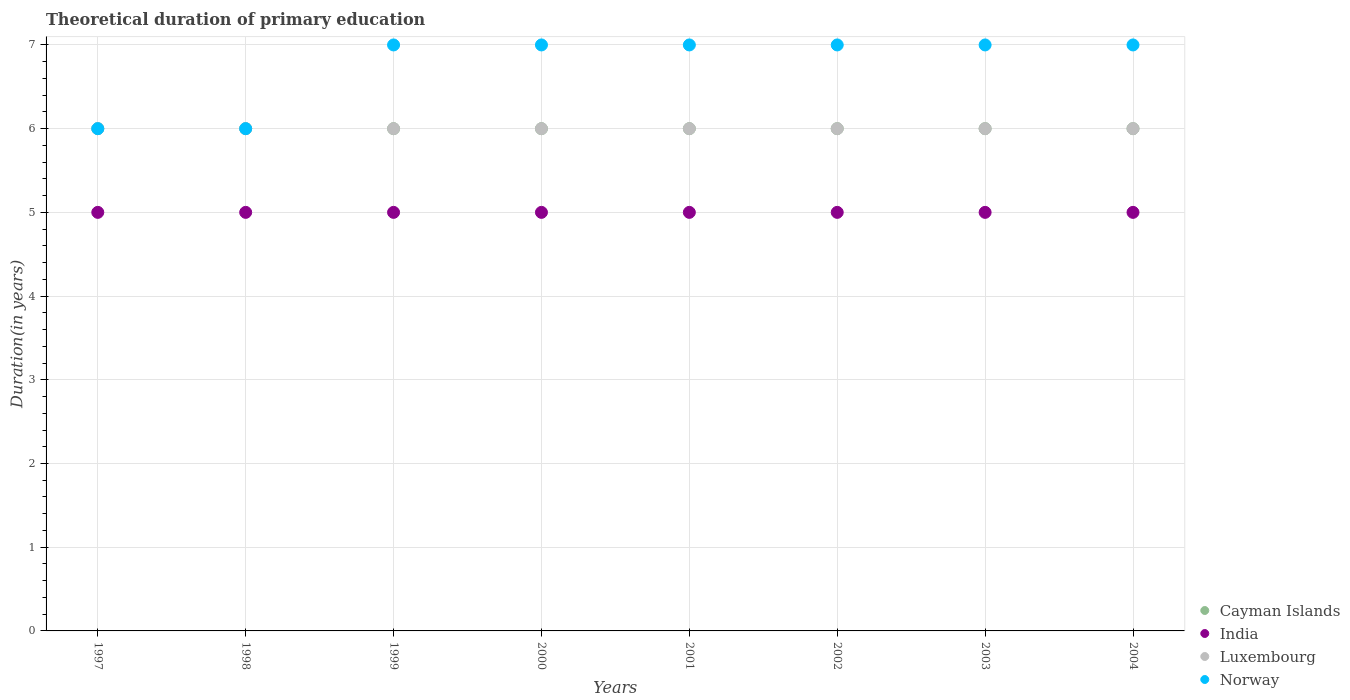How many different coloured dotlines are there?
Your response must be concise. 4. What is the total theoretical duration of primary education in Luxembourg in 2001?
Your answer should be very brief. 6. Across all years, what is the maximum total theoretical duration of primary education in Norway?
Offer a very short reply. 7. Across all years, what is the minimum total theoretical duration of primary education in India?
Your answer should be compact. 5. In which year was the total theoretical duration of primary education in Norway maximum?
Provide a succinct answer. 1999. In which year was the total theoretical duration of primary education in Norway minimum?
Give a very brief answer. 1997. What is the total total theoretical duration of primary education in India in the graph?
Give a very brief answer. 40. What is the average total theoretical duration of primary education in Norway per year?
Your response must be concise. 6.75. In the year 1997, what is the difference between the total theoretical duration of primary education in Cayman Islands and total theoretical duration of primary education in India?
Keep it short and to the point. 1. Is the total theoretical duration of primary education in Norway in 1999 less than that in 2003?
Your answer should be very brief. No. What is the difference between the highest and the second highest total theoretical duration of primary education in Cayman Islands?
Keep it short and to the point. 0. What is the difference between the highest and the lowest total theoretical duration of primary education in Norway?
Offer a terse response. 1. Is the sum of the total theoretical duration of primary education in India in 1999 and 2000 greater than the maximum total theoretical duration of primary education in Luxembourg across all years?
Give a very brief answer. Yes. Is it the case that in every year, the sum of the total theoretical duration of primary education in Luxembourg and total theoretical duration of primary education in India  is greater than the sum of total theoretical duration of primary education in Norway and total theoretical duration of primary education in Cayman Islands?
Offer a terse response. Yes. Is it the case that in every year, the sum of the total theoretical duration of primary education in Luxembourg and total theoretical duration of primary education in Norway  is greater than the total theoretical duration of primary education in India?
Offer a terse response. Yes. Does the total theoretical duration of primary education in Norway monotonically increase over the years?
Offer a terse response. No. Is the total theoretical duration of primary education in Luxembourg strictly greater than the total theoretical duration of primary education in Norway over the years?
Give a very brief answer. No. Is the total theoretical duration of primary education in Cayman Islands strictly less than the total theoretical duration of primary education in India over the years?
Provide a succinct answer. No. How many dotlines are there?
Make the answer very short. 4. How many years are there in the graph?
Your answer should be very brief. 8. Does the graph contain any zero values?
Offer a terse response. No. Where does the legend appear in the graph?
Provide a short and direct response. Bottom right. How many legend labels are there?
Provide a succinct answer. 4. How are the legend labels stacked?
Your answer should be compact. Vertical. What is the title of the graph?
Your answer should be very brief. Theoretical duration of primary education. Does "Kyrgyz Republic" appear as one of the legend labels in the graph?
Make the answer very short. No. What is the label or title of the Y-axis?
Ensure brevity in your answer.  Duration(in years). What is the Duration(in years) of Cayman Islands in 1997?
Offer a terse response. 6. What is the Duration(in years) in India in 1997?
Your answer should be very brief. 5. What is the Duration(in years) of Cayman Islands in 1998?
Your response must be concise. 6. What is the Duration(in years) of Luxembourg in 1998?
Your answer should be very brief. 6. What is the Duration(in years) of Norway in 1998?
Give a very brief answer. 6. What is the Duration(in years) of India in 1999?
Your response must be concise. 5. What is the Duration(in years) of Luxembourg in 1999?
Your answer should be compact. 6. What is the Duration(in years) of Norway in 1999?
Your response must be concise. 7. What is the Duration(in years) of India in 2000?
Offer a very short reply. 5. What is the Duration(in years) in Cayman Islands in 2001?
Your answer should be compact. 6. What is the Duration(in years) of India in 2001?
Provide a short and direct response. 5. What is the Duration(in years) of Cayman Islands in 2002?
Provide a short and direct response. 6. What is the Duration(in years) of Cayman Islands in 2003?
Keep it short and to the point. 6. What is the Duration(in years) of India in 2003?
Your response must be concise. 5. What is the Duration(in years) of Luxembourg in 2003?
Your answer should be compact. 6. What is the Duration(in years) of Cayman Islands in 2004?
Offer a terse response. 6. What is the Duration(in years) in Norway in 2004?
Make the answer very short. 7. Across all years, what is the maximum Duration(in years) of Cayman Islands?
Ensure brevity in your answer.  6. Across all years, what is the maximum Duration(in years) of Luxembourg?
Offer a very short reply. 6. Across all years, what is the minimum Duration(in years) in India?
Your response must be concise. 5. What is the total Duration(in years) in Norway in the graph?
Offer a very short reply. 54. What is the difference between the Duration(in years) in Cayman Islands in 1997 and that in 1999?
Provide a succinct answer. 0. What is the difference between the Duration(in years) in Norway in 1997 and that in 1999?
Your answer should be compact. -1. What is the difference between the Duration(in years) of India in 1997 and that in 2000?
Ensure brevity in your answer.  0. What is the difference between the Duration(in years) of Luxembourg in 1997 and that in 2000?
Provide a succinct answer. 0. What is the difference between the Duration(in years) of Norway in 1997 and that in 2000?
Make the answer very short. -1. What is the difference between the Duration(in years) in Cayman Islands in 1997 and that in 2001?
Ensure brevity in your answer.  0. What is the difference between the Duration(in years) of India in 1997 and that in 2001?
Give a very brief answer. 0. What is the difference between the Duration(in years) in Norway in 1997 and that in 2001?
Offer a very short reply. -1. What is the difference between the Duration(in years) of India in 1997 and that in 2002?
Provide a short and direct response. 0. What is the difference between the Duration(in years) of Cayman Islands in 1997 and that in 2003?
Your answer should be very brief. 0. What is the difference between the Duration(in years) of Luxembourg in 1997 and that in 2003?
Ensure brevity in your answer.  0. What is the difference between the Duration(in years) in India in 1997 and that in 2004?
Give a very brief answer. 0. What is the difference between the Duration(in years) of Luxembourg in 1997 and that in 2004?
Make the answer very short. 0. What is the difference between the Duration(in years) of Norway in 1997 and that in 2004?
Your response must be concise. -1. What is the difference between the Duration(in years) of Luxembourg in 1998 and that in 1999?
Make the answer very short. 0. What is the difference between the Duration(in years) in Cayman Islands in 1998 and that in 2000?
Make the answer very short. 0. What is the difference between the Duration(in years) of India in 1998 and that in 2000?
Offer a very short reply. 0. What is the difference between the Duration(in years) of Luxembourg in 1998 and that in 2000?
Make the answer very short. 0. What is the difference between the Duration(in years) in Cayman Islands in 1998 and that in 2001?
Your response must be concise. 0. What is the difference between the Duration(in years) in India in 1998 and that in 2001?
Offer a very short reply. 0. What is the difference between the Duration(in years) of Luxembourg in 1998 and that in 2001?
Keep it short and to the point. 0. What is the difference between the Duration(in years) in Luxembourg in 1998 and that in 2002?
Offer a terse response. 0. What is the difference between the Duration(in years) of Norway in 1998 and that in 2002?
Offer a terse response. -1. What is the difference between the Duration(in years) of India in 1998 and that in 2004?
Your response must be concise. 0. What is the difference between the Duration(in years) in Luxembourg in 1999 and that in 2000?
Your answer should be very brief. 0. What is the difference between the Duration(in years) in Norway in 1999 and that in 2000?
Offer a terse response. 0. What is the difference between the Duration(in years) of India in 1999 and that in 2001?
Provide a short and direct response. 0. What is the difference between the Duration(in years) of Luxembourg in 1999 and that in 2001?
Make the answer very short. 0. What is the difference between the Duration(in years) of Norway in 1999 and that in 2001?
Keep it short and to the point. 0. What is the difference between the Duration(in years) of Cayman Islands in 1999 and that in 2002?
Your answer should be very brief. 0. What is the difference between the Duration(in years) in Luxembourg in 1999 and that in 2002?
Your answer should be very brief. 0. What is the difference between the Duration(in years) in Norway in 1999 and that in 2002?
Your answer should be compact. 0. What is the difference between the Duration(in years) in India in 1999 and that in 2003?
Offer a very short reply. 0. What is the difference between the Duration(in years) in Luxembourg in 1999 and that in 2003?
Your answer should be compact. 0. What is the difference between the Duration(in years) in Norway in 1999 and that in 2003?
Offer a very short reply. 0. What is the difference between the Duration(in years) of Cayman Islands in 2000 and that in 2001?
Ensure brevity in your answer.  0. What is the difference between the Duration(in years) in Luxembourg in 2000 and that in 2001?
Make the answer very short. 0. What is the difference between the Duration(in years) of Norway in 2000 and that in 2001?
Offer a terse response. 0. What is the difference between the Duration(in years) in India in 2000 and that in 2002?
Ensure brevity in your answer.  0. What is the difference between the Duration(in years) of Norway in 2000 and that in 2002?
Give a very brief answer. 0. What is the difference between the Duration(in years) of Luxembourg in 2000 and that in 2003?
Your answer should be very brief. 0. What is the difference between the Duration(in years) of Norway in 2000 and that in 2003?
Your answer should be very brief. 0. What is the difference between the Duration(in years) in India in 2000 and that in 2004?
Provide a succinct answer. 0. What is the difference between the Duration(in years) of Norway in 2000 and that in 2004?
Make the answer very short. 0. What is the difference between the Duration(in years) in Cayman Islands in 2001 and that in 2002?
Keep it short and to the point. 0. What is the difference between the Duration(in years) in India in 2001 and that in 2002?
Keep it short and to the point. 0. What is the difference between the Duration(in years) of Cayman Islands in 2001 and that in 2003?
Offer a terse response. 0. What is the difference between the Duration(in years) in Norway in 2001 and that in 2004?
Provide a short and direct response. 0. What is the difference between the Duration(in years) in India in 2002 and that in 2003?
Give a very brief answer. 0. What is the difference between the Duration(in years) in Cayman Islands in 2002 and that in 2004?
Keep it short and to the point. 0. What is the difference between the Duration(in years) of India in 2002 and that in 2004?
Keep it short and to the point. 0. What is the difference between the Duration(in years) in Norway in 2002 and that in 2004?
Your answer should be compact. 0. What is the difference between the Duration(in years) in India in 2003 and that in 2004?
Make the answer very short. 0. What is the difference between the Duration(in years) in Norway in 2003 and that in 2004?
Offer a very short reply. 0. What is the difference between the Duration(in years) in Cayman Islands in 1997 and the Duration(in years) in India in 1998?
Provide a short and direct response. 1. What is the difference between the Duration(in years) of Cayman Islands in 1997 and the Duration(in years) of Luxembourg in 1998?
Make the answer very short. 0. What is the difference between the Duration(in years) of India in 1997 and the Duration(in years) of Luxembourg in 1998?
Offer a very short reply. -1. What is the difference between the Duration(in years) in Cayman Islands in 1997 and the Duration(in years) in India in 1999?
Make the answer very short. 1. What is the difference between the Duration(in years) of Cayman Islands in 1997 and the Duration(in years) of Luxembourg in 1999?
Make the answer very short. 0. What is the difference between the Duration(in years) of India in 1997 and the Duration(in years) of Norway in 1999?
Your answer should be compact. -2. What is the difference between the Duration(in years) of Luxembourg in 1997 and the Duration(in years) of Norway in 1999?
Provide a short and direct response. -1. What is the difference between the Duration(in years) in Cayman Islands in 1997 and the Duration(in years) in Luxembourg in 2000?
Offer a terse response. 0. What is the difference between the Duration(in years) in India in 1997 and the Duration(in years) in Luxembourg in 2000?
Your answer should be very brief. -1. What is the difference between the Duration(in years) of Cayman Islands in 1997 and the Duration(in years) of India in 2001?
Offer a terse response. 1. What is the difference between the Duration(in years) in India in 1997 and the Duration(in years) in Norway in 2001?
Keep it short and to the point. -2. What is the difference between the Duration(in years) in Cayman Islands in 1997 and the Duration(in years) in Luxembourg in 2002?
Offer a very short reply. 0. What is the difference between the Duration(in years) in India in 1997 and the Duration(in years) in Luxembourg in 2002?
Your response must be concise. -1. What is the difference between the Duration(in years) of India in 1997 and the Duration(in years) of Norway in 2002?
Keep it short and to the point. -2. What is the difference between the Duration(in years) in Cayman Islands in 1997 and the Duration(in years) in India in 2003?
Ensure brevity in your answer.  1. What is the difference between the Duration(in years) in Cayman Islands in 1997 and the Duration(in years) in Norway in 2003?
Provide a short and direct response. -1. What is the difference between the Duration(in years) in India in 1997 and the Duration(in years) in Norway in 2003?
Offer a terse response. -2. What is the difference between the Duration(in years) in Luxembourg in 1997 and the Duration(in years) in Norway in 2003?
Your response must be concise. -1. What is the difference between the Duration(in years) of Cayman Islands in 1997 and the Duration(in years) of India in 2004?
Keep it short and to the point. 1. What is the difference between the Duration(in years) in India in 1997 and the Duration(in years) in Luxembourg in 2004?
Keep it short and to the point. -1. What is the difference between the Duration(in years) of Cayman Islands in 1998 and the Duration(in years) of India in 1999?
Your answer should be compact. 1. What is the difference between the Duration(in years) of Cayman Islands in 1998 and the Duration(in years) of Luxembourg in 1999?
Your answer should be compact. 0. What is the difference between the Duration(in years) of India in 1998 and the Duration(in years) of Norway in 1999?
Offer a very short reply. -2. What is the difference between the Duration(in years) in Luxembourg in 1998 and the Duration(in years) in Norway in 1999?
Ensure brevity in your answer.  -1. What is the difference between the Duration(in years) in Cayman Islands in 1998 and the Duration(in years) in India in 2000?
Provide a succinct answer. 1. What is the difference between the Duration(in years) of Cayman Islands in 1998 and the Duration(in years) of Luxembourg in 2000?
Offer a very short reply. 0. What is the difference between the Duration(in years) of India in 1998 and the Duration(in years) of Norway in 2000?
Offer a very short reply. -2. What is the difference between the Duration(in years) of Luxembourg in 1998 and the Duration(in years) of Norway in 2000?
Offer a very short reply. -1. What is the difference between the Duration(in years) in India in 1998 and the Duration(in years) in Norway in 2001?
Ensure brevity in your answer.  -2. What is the difference between the Duration(in years) in Luxembourg in 1998 and the Duration(in years) in Norway in 2001?
Your answer should be very brief. -1. What is the difference between the Duration(in years) of Cayman Islands in 1998 and the Duration(in years) of Norway in 2002?
Your answer should be compact. -1. What is the difference between the Duration(in years) in India in 1998 and the Duration(in years) in Luxembourg in 2002?
Your response must be concise. -1. What is the difference between the Duration(in years) in India in 1998 and the Duration(in years) in Norway in 2002?
Your answer should be compact. -2. What is the difference between the Duration(in years) in Luxembourg in 1998 and the Duration(in years) in Norway in 2002?
Offer a terse response. -1. What is the difference between the Duration(in years) in India in 1998 and the Duration(in years) in Luxembourg in 2003?
Your response must be concise. -1. What is the difference between the Duration(in years) of Cayman Islands in 1998 and the Duration(in years) of India in 2004?
Ensure brevity in your answer.  1. What is the difference between the Duration(in years) in Cayman Islands in 1998 and the Duration(in years) in Luxembourg in 2004?
Your answer should be compact. 0. What is the difference between the Duration(in years) in Cayman Islands in 1998 and the Duration(in years) in Norway in 2004?
Ensure brevity in your answer.  -1. What is the difference between the Duration(in years) in Cayman Islands in 1999 and the Duration(in years) in Luxembourg in 2000?
Give a very brief answer. 0. What is the difference between the Duration(in years) of India in 1999 and the Duration(in years) of Norway in 2000?
Offer a very short reply. -2. What is the difference between the Duration(in years) of Luxembourg in 1999 and the Duration(in years) of Norway in 2000?
Provide a short and direct response. -1. What is the difference between the Duration(in years) in India in 1999 and the Duration(in years) in Luxembourg in 2001?
Offer a very short reply. -1. What is the difference between the Duration(in years) of Cayman Islands in 1999 and the Duration(in years) of India in 2002?
Offer a very short reply. 1. What is the difference between the Duration(in years) of Cayman Islands in 1999 and the Duration(in years) of Luxembourg in 2002?
Keep it short and to the point. 0. What is the difference between the Duration(in years) of India in 1999 and the Duration(in years) of Norway in 2002?
Ensure brevity in your answer.  -2. What is the difference between the Duration(in years) of Cayman Islands in 1999 and the Duration(in years) of India in 2003?
Your response must be concise. 1. What is the difference between the Duration(in years) of Cayman Islands in 1999 and the Duration(in years) of Luxembourg in 2003?
Offer a very short reply. 0. What is the difference between the Duration(in years) in India in 1999 and the Duration(in years) in Luxembourg in 2003?
Offer a terse response. -1. What is the difference between the Duration(in years) in India in 1999 and the Duration(in years) in Norway in 2003?
Offer a very short reply. -2. What is the difference between the Duration(in years) of Cayman Islands in 1999 and the Duration(in years) of Luxembourg in 2004?
Your answer should be very brief. 0. What is the difference between the Duration(in years) of India in 1999 and the Duration(in years) of Luxembourg in 2004?
Your answer should be very brief. -1. What is the difference between the Duration(in years) of India in 1999 and the Duration(in years) of Norway in 2004?
Keep it short and to the point. -2. What is the difference between the Duration(in years) of Cayman Islands in 2000 and the Duration(in years) of India in 2001?
Your answer should be very brief. 1. What is the difference between the Duration(in years) in Cayman Islands in 2000 and the Duration(in years) in Luxembourg in 2001?
Make the answer very short. 0. What is the difference between the Duration(in years) in Cayman Islands in 2000 and the Duration(in years) in Norway in 2001?
Give a very brief answer. -1. What is the difference between the Duration(in years) in Luxembourg in 2000 and the Duration(in years) in Norway in 2001?
Offer a very short reply. -1. What is the difference between the Duration(in years) in Cayman Islands in 2000 and the Duration(in years) in India in 2002?
Your answer should be compact. 1. What is the difference between the Duration(in years) of Cayman Islands in 2000 and the Duration(in years) of Luxembourg in 2002?
Ensure brevity in your answer.  0. What is the difference between the Duration(in years) in Cayman Islands in 2000 and the Duration(in years) in Norway in 2002?
Give a very brief answer. -1. What is the difference between the Duration(in years) in India in 2000 and the Duration(in years) in Luxembourg in 2002?
Give a very brief answer. -1. What is the difference between the Duration(in years) of India in 2000 and the Duration(in years) of Norway in 2002?
Your response must be concise. -2. What is the difference between the Duration(in years) in Cayman Islands in 2000 and the Duration(in years) in India in 2003?
Provide a succinct answer. 1. What is the difference between the Duration(in years) in Cayman Islands in 2000 and the Duration(in years) in Luxembourg in 2003?
Your answer should be compact. 0. What is the difference between the Duration(in years) in Cayman Islands in 2000 and the Duration(in years) in Norway in 2003?
Your answer should be very brief. -1. What is the difference between the Duration(in years) in India in 2000 and the Duration(in years) in Luxembourg in 2003?
Offer a very short reply. -1. What is the difference between the Duration(in years) in India in 2000 and the Duration(in years) in Norway in 2003?
Keep it short and to the point. -2. What is the difference between the Duration(in years) of Cayman Islands in 2000 and the Duration(in years) of India in 2004?
Give a very brief answer. 1. What is the difference between the Duration(in years) in Cayman Islands in 2000 and the Duration(in years) in Norway in 2004?
Give a very brief answer. -1. What is the difference between the Duration(in years) of India in 2000 and the Duration(in years) of Luxembourg in 2004?
Keep it short and to the point. -1. What is the difference between the Duration(in years) in India in 2000 and the Duration(in years) in Norway in 2004?
Give a very brief answer. -2. What is the difference between the Duration(in years) of Cayman Islands in 2001 and the Duration(in years) of India in 2002?
Provide a succinct answer. 1. What is the difference between the Duration(in years) in Cayman Islands in 2001 and the Duration(in years) in Luxembourg in 2002?
Keep it short and to the point. 0. What is the difference between the Duration(in years) in Cayman Islands in 2001 and the Duration(in years) in Norway in 2002?
Provide a short and direct response. -1. What is the difference between the Duration(in years) of India in 2001 and the Duration(in years) of Norway in 2002?
Make the answer very short. -2. What is the difference between the Duration(in years) of Cayman Islands in 2001 and the Duration(in years) of Norway in 2003?
Ensure brevity in your answer.  -1. What is the difference between the Duration(in years) in Cayman Islands in 2001 and the Duration(in years) in Luxembourg in 2004?
Your answer should be compact. 0. What is the difference between the Duration(in years) of Cayman Islands in 2001 and the Duration(in years) of Norway in 2004?
Give a very brief answer. -1. What is the difference between the Duration(in years) of India in 2001 and the Duration(in years) of Luxembourg in 2004?
Provide a succinct answer. -1. What is the difference between the Duration(in years) in India in 2001 and the Duration(in years) in Norway in 2004?
Keep it short and to the point. -2. What is the difference between the Duration(in years) of Cayman Islands in 2002 and the Duration(in years) of India in 2003?
Give a very brief answer. 1. What is the difference between the Duration(in years) of Cayman Islands in 2002 and the Duration(in years) of Luxembourg in 2003?
Your response must be concise. 0. What is the difference between the Duration(in years) in Cayman Islands in 2002 and the Duration(in years) in Norway in 2003?
Ensure brevity in your answer.  -1. What is the difference between the Duration(in years) in Luxembourg in 2002 and the Duration(in years) in Norway in 2003?
Keep it short and to the point. -1. What is the difference between the Duration(in years) in Cayman Islands in 2002 and the Duration(in years) in India in 2004?
Offer a very short reply. 1. What is the difference between the Duration(in years) of Cayman Islands in 2002 and the Duration(in years) of Luxembourg in 2004?
Give a very brief answer. 0. What is the difference between the Duration(in years) of Cayman Islands in 2002 and the Duration(in years) of Norway in 2004?
Offer a terse response. -1. What is the difference between the Duration(in years) of India in 2002 and the Duration(in years) of Norway in 2004?
Keep it short and to the point. -2. What is the difference between the Duration(in years) of Luxembourg in 2002 and the Duration(in years) of Norway in 2004?
Offer a terse response. -1. What is the difference between the Duration(in years) of Cayman Islands in 2003 and the Duration(in years) of India in 2004?
Your answer should be very brief. 1. What is the difference between the Duration(in years) in Cayman Islands in 2003 and the Duration(in years) in Luxembourg in 2004?
Give a very brief answer. 0. What is the difference between the Duration(in years) of India in 2003 and the Duration(in years) of Luxembourg in 2004?
Your answer should be very brief. -1. What is the difference between the Duration(in years) in India in 2003 and the Duration(in years) in Norway in 2004?
Offer a very short reply. -2. What is the average Duration(in years) in Cayman Islands per year?
Make the answer very short. 6. What is the average Duration(in years) in India per year?
Give a very brief answer. 5. What is the average Duration(in years) in Luxembourg per year?
Provide a succinct answer. 6. What is the average Duration(in years) of Norway per year?
Provide a succinct answer. 6.75. In the year 1997, what is the difference between the Duration(in years) in Cayman Islands and Duration(in years) in India?
Offer a terse response. 1. In the year 1997, what is the difference between the Duration(in years) in Cayman Islands and Duration(in years) in Luxembourg?
Your response must be concise. 0. In the year 1997, what is the difference between the Duration(in years) of Cayman Islands and Duration(in years) of Norway?
Ensure brevity in your answer.  0. In the year 1997, what is the difference between the Duration(in years) of India and Duration(in years) of Luxembourg?
Ensure brevity in your answer.  -1. In the year 1997, what is the difference between the Duration(in years) in India and Duration(in years) in Norway?
Keep it short and to the point. -1. In the year 1998, what is the difference between the Duration(in years) of Cayman Islands and Duration(in years) of Norway?
Keep it short and to the point. 0. In the year 1999, what is the difference between the Duration(in years) of Cayman Islands and Duration(in years) of India?
Ensure brevity in your answer.  1. In the year 1999, what is the difference between the Duration(in years) in India and Duration(in years) in Norway?
Offer a terse response. -2. In the year 2000, what is the difference between the Duration(in years) of Cayman Islands and Duration(in years) of India?
Your answer should be compact. 1. In the year 2000, what is the difference between the Duration(in years) in India and Duration(in years) in Luxembourg?
Offer a very short reply. -1. In the year 2000, what is the difference between the Duration(in years) in India and Duration(in years) in Norway?
Keep it short and to the point. -2. In the year 2001, what is the difference between the Duration(in years) in India and Duration(in years) in Norway?
Keep it short and to the point. -2. In the year 2001, what is the difference between the Duration(in years) in Luxembourg and Duration(in years) in Norway?
Offer a very short reply. -1. In the year 2002, what is the difference between the Duration(in years) of Cayman Islands and Duration(in years) of Luxembourg?
Make the answer very short. 0. In the year 2002, what is the difference between the Duration(in years) in Cayman Islands and Duration(in years) in Norway?
Your response must be concise. -1. In the year 2002, what is the difference between the Duration(in years) in Luxembourg and Duration(in years) in Norway?
Your answer should be compact. -1. In the year 2003, what is the difference between the Duration(in years) in Cayman Islands and Duration(in years) in India?
Ensure brevity in your answer.  1. In the year 2003, what is the difference between the Duration(in years) of India and Duration(in years) of Luxembourg?
Make the answer very short. -1. In the year 2003, what is the difference between the Duration(in years) in India and Duration(in years) in Norway?
Your response must be concise. -2. In the year 2003, what is the difference between the Duration(in years) in Luxembourg and Duration(in years) in Norway?
Keep it short and to the point. -1. In the year 2004, what is the difference between the Duration(in years) of Cayman Islands and Duration(in years) of Luxembourg?
Offer a terse response. 0. In the year 2004, what is the difference between the Duration(in years) in Cayman Islands and Duration(in years) in Norway?
Offer a very short reply. -1. In the year 2004, what is the difference between the Duration(in years) of India and Duration(in years) of Norway?
Give a very brief answer. -2. What is the ratio of the Duration(in years) in Cayman Islands in 1997 to that in 1998?
Your answer should be very brief. 1. What is the ratio of the Duration(in years) in Luxembourg in 1997 to that in 1999?
Offer a very short reply. 1. What is the ratio of the Duration(in years) in India in 1997 to that in 2000?
Your answer should be compact. 1. What is the ratio of the Duration(in years) of Luxembourg in 1997 to that in 2000?
Give a very brief answer. 1. What is the ratio of the Duration(in years) of Cayman Islands in 1997 to that in 2001?
Keep it short and to the point. 1. What is the ratio of the Duration(in years) in India in 1997 to that in 2001?
Make the answer very short. 1. What is the ratio of the Duration(in years) of Norway in 1997 to that in 2001?
Ensure brevity in your answer.  0.86. What is the ratio of the Duration(in years) in Cayman Islands in 1997 to that in 2002?
Give a very brief answer. 1. What is the ratio of the Duration(in years) in India in 1997 to that in 2002?
Your response must be concise. 1. What is the ratio of the Duration(in years) in Luxembourg in 1997 to that in 2003?
Keep it short and to the point. 1. What is the ratio of the Duration(in years) of Norway in 1997 to that in 2003?
Offer a very short reply. 0.86. What is the ratio of the Duration(in years) of India in 1997 to that in 2004?
Keep it short and to the point. 1. What is the ratio of the Duration(in years) of Norway in 1997 to that in 2004?
Your answer should be very brief. 0.86. What is the ratio of the Duration(in years) of India in 1998 to that in 1999?
Your answer should be compact. 1. What is the ratio of the Duration(in years) of Norway in 1998 to that in 1999?
Your response must be concise. 0.86. What is the ratio of the Duration(in years) in Luxembourg in 1998 to that in 2000?
Your answer should be compact. 1. What is the ratio of the Duration(in years) of Cayman Islands in 1998 to that in 2002?
Your answer should be very brief. 1. What is the ratio of the Duration(in years) in India in 1998 to that in 2002?
Your response must be concise. 1. What is the ratio of the Duration(in years) of Norway in 1998 to that in 2002?
Give a very brief answer. 0.86. What is the ratio of the Duration(in years) of Cayman Islands in 1998 to that in 2003?
Your answer should be compact. 1. What is the ratio of the Duration(in years) of Luxembourg in 1998 to that in 2003?
Provide a short and direct response. 1. What is the ratio of the Duration(in years) of Norway in 1998 to that in 2003?
Keep it short and to the point. 0.86. What is the ratio of the Duration(in years) in Cayman Islands in 1998 to that in 2004?
Your answer should be very brief. 1. What is the ratio of the Duration(in years) in India in 1998 to that in 2004?
Your answer should be very brief. 1. What is the ratio of the Duration(in years) of Luxembourg in 1998 to that in 2004?
Offer a terse response. 1. What is the ratio of the Duration(in years) in Cayman Islands in 1999 to that in 2000?
Provide a short and direct response. 1. What is the ratio of the Duration(in years) of Luxembourg in 1999 to that in 2000?
Keep it short and to the point. 1. What is the ratio of the Duration(in years) in Norway in 1999 to that in 2000?
Provide a short and direct response. 1. What is the ratio of the Duration(in years) of India in 1999 to that in 2001?
Your answer should be compact. 1. What is the ratio of the Duration(in years) in Norway in 1999 to that in 2001?
Offer a very short reply. 1. What is the ratio of the Duration(in years) in Norway in 1999 to that in 2002?
Offer a terse response. 1. What is the ratio of the Duration(in years) in Luxembourg in 1999 to that in 2003?
Your answer should be very brief. 1. What is the ratio of the Duration(in years) in Norway in 1999 to that in 2003?
Your response must be concise. 1. What is the ratio of the Duration(in years) in Cayman Islands in 2000 to that in 2001?
Give a very brief answer. 1. What is the ratio of the Duration(in years) in Luxembourg in 2000 to that in 2001?
Offer a very short reply. 1. What is the ratio of the Duration(in years) of Norway in 2000 to that in 2001?
Ensure brevity in your answer.  1. What is the ratio of the Duration(in years) in Cayman Islands in 2000 to that in 2002?
Your answer should be very brief. 1. What is the ratio of the Duration(in years) of Norway in 2000 to that in 2002?
Ensure brevity in your answer.  1. What is the ratio of the Duration(in years) in India in 2000 to that in 2003?
Your answer should be compact. 1. What is the ratio of the Duration(in years) in India in 2000 to that in 2004?
Offer a terse response. 1. What is the ratio of the Duration(in years) of Norway in 2000 to that in 2004?
Provide a short and direct response. 1. What is the ratio of the Duration(in years) of India in 2001 to that in 2002?
Ensure brevity in your answer.  1. What is the ratio of the Duration(in years) in Luxembourg in 2001 to that in 2002?
Provide a short and direct response. 1. What is the ratio of the Duration(in years) in Norway in 2001 to that in 2002?
Your answer should be compact. 1. What is the ratio of the Duration(in years) of India in 2001 to that in 2003?
Offer a terse response. 1. What is the ratio of the Duration(in years) in Luxembourg in 2001 to that in 2003?
Provide a succinct answer. 1. What is the ratio of the Duration(in years) of Norway in 2001 to that in 2003?
Offer a very short reply. 1. What is the ratio of the Duration(in years) of Cayman Islands in 2001 to that in 2004?
Your response must be concise. 1. What is the ratio of the Duration(in years) of India in 2001 to that in 2004?
Offer a terse response. 1. What is the ratio of the Duration(in years) in India in 2002 to that in 2003?
Your response must be concise. 1. What is the ratio of the Duration(in years) in Luxembourg in 2002 to that in 2003?
Keep it short and to the point. 1. What is the ratio of the Duration(in years) of Cayman Islands in 2002 to that in 2004?
Your response must be concise. 1. What is the ratio of the Duration(in years) of India in 2002 to that in 2004?
Make the answer very short. 1. What is the ratio of the Duration(in years) of Luxembourg in 2002 to that in 2004?
Give a very brief answer. 1. What is the ratio of the Duration(in years) in Norway in 2002 to that in 2004?
Your response must be concise. 1. What is the ratio of the Duration(in years) of Cayman Islands in 2003 to that in 2004?
Provide a short and direct response. 1. What is the ratio of the Duration(in years) of India in 2003 to that in 2004?
Provide a succinct answer. 1. What is the ratio of the Duration(in years) in Luxembourg in 2003 to that in 2004?
Your response must be concise. 1. What is the ratio of the Duration(in years) of Norway in 2003 to that in 2004?
Provide a short and direct response. 1. What is the difference between the highest and the second highest Duration(in years) in India?
Ensure brevity in your answer.  0. What is the difference between the highest and the second highest Duration(in years) of Luxembourg?
Your answer should be very brief. 0. What is the difference between the highest and the second highest Duration(in years) in Norway?
Your answer should be very brief. 0. What is the difference between the highest and the lowest Duration(in years) of Norway?
Ensure brevity in your answer.  1. 